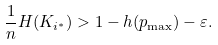Convert formula to latex. <formula><loc_0><loc_0><loc_500><loc_500>\frac { 1 } { n } H ( K _ { i ^ { * } } ) > 1 - h ( p _ { \max } ) - \varepsilon .</formula> 